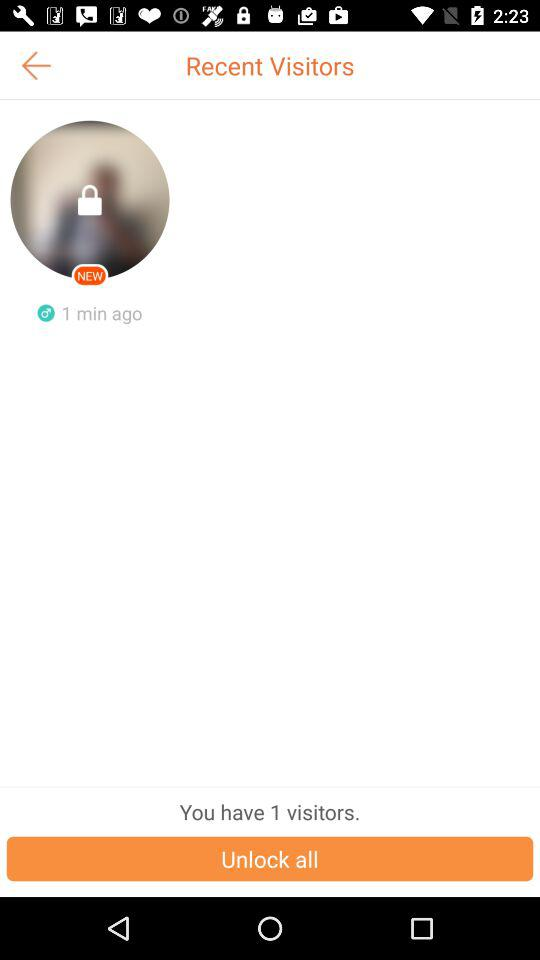What's the number of visitors? The number of visitors is 1. 